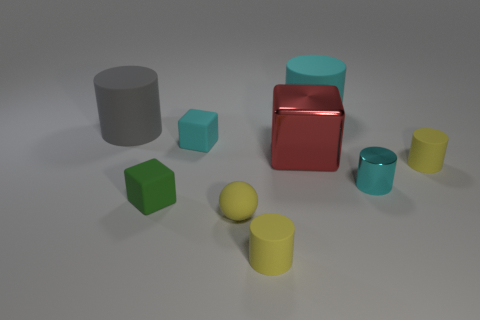Subtract all small cyan cylinders. How many cylinders are left? 4 Subtract all gray cylinders. How many cylinders are left? 4 Subtract all cylinders. How many objects are left? 4 Subtract all blue blocks. How many brown cylinders are left? 0 Subtract all large yellow things. Subtract all large cyan matte cylinders. How many objects are left? 8 Add 1 cylinders. How many cylinders are left? 6 Add 6 tiny green objects. How many tiny green objects exist? 7 Subtract 2 cyan cylinders. How many objects are left? 7 Subtract 1 cylinders. How many cylinders are left? 4 Subtract all green cubes. Subtract all green cylinders. How many cubes are left? 2 